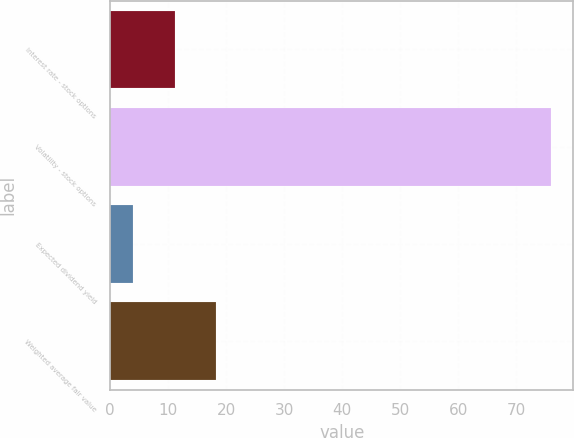<chart> <loc_0><loc_0><loc_500><loc_500><bar_chart><fcel>Interest rate - stock options<fcel>Volatility - stock options<fcel>Expected dividend yield<fcel>Weighted average fair value<nl><fcel>11.09<fcel>76<fcel>3.88<fcel>18.3<nl></chart> 